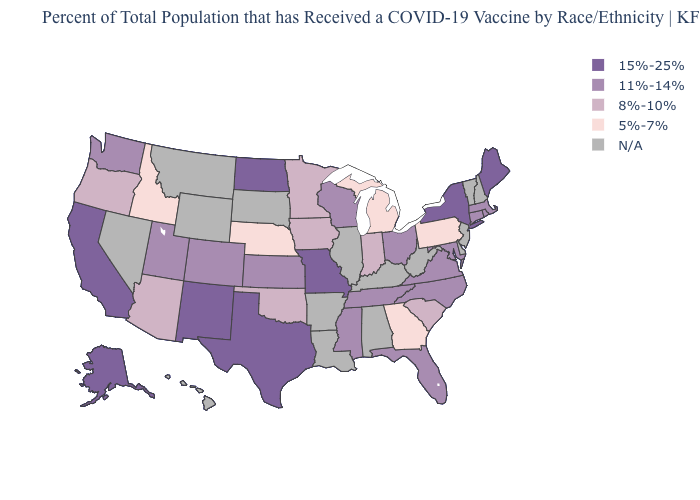What is the lowest value in the USA?
Answer briefly. 5%-7%. What is the lowest value in the USA?
Write a very short answer. 5%-7%. What is the value of Arkansas?
Write a very short answer. N/A. Name the states that have a value in the range 8%-10%?
Write a very short answer. Arizona, Indiana, Iowa, Minnesota, Oklahoma, Oregon, South Carolina. What is the value of New Jersey?
Give a very brief answer. N/A. What is the value of South Dakota?
Answer briefly. N/A. What is the value of Hawaii?
Write a very short answer. N/A. What is the highest value in states that border Utah?
Keep it brief. 15%-25%. Does North Dakota have the highest value in the MidWest?
Write a very short answer. Yes. What is the highest value in states that border Nevada?
Write a very short answer. 15%-25%. What is the lowest value in the South?
Give a very brief answer. 5%-7%. What is the value of South Dakota?
Give a very brief answer. N/A. Name the states that have a value in the range 11%-14%?
Short answer required. Colorado, Connecticut, Florida, Kansas, Maryland, Massachusetts, Mississippi, North Carolina, Ohio, Rhode Island, Tennessee, Utah, Virginia, Washington, Wisconsin. What is the value of West Virginia?
Be succinct. N/A. 